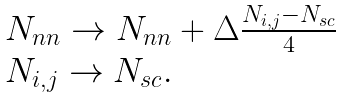Convert formula to latex. <formula><loc_0><loc_0><loc_500><loc_500>\begin{array} { l } N _ { n n } \rightarrow N _ { n n } + \Delta \frac { N _ { i , j } - N _ { s c } } { 4 } \\ N _ { i , j } \rightarrow N _ { s c } . \end{array}</formula> 